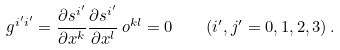Convert formula to latex. <formula><loc_0><loc_0><loc_500><loc_500>g ^ { { i ^ { \prime } } { i ^ { \prime } } } = \frac { \partial s ^ { i ^ { \prime } } } { \partial x ^ { k } } \frac { \partial s ^ { i ^ { \prime } } } { \partial x ^ { l } } \, o ^ { k l } = 0 \quad ( { i ^ { \prime } } , j ^ { \prime } = 0 , 1 , 2 , 3 ) \, .</formula> 